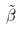<formula> <loc_0><loc_0><loc_500><loc_500>\tilde { \beta }</formula> 